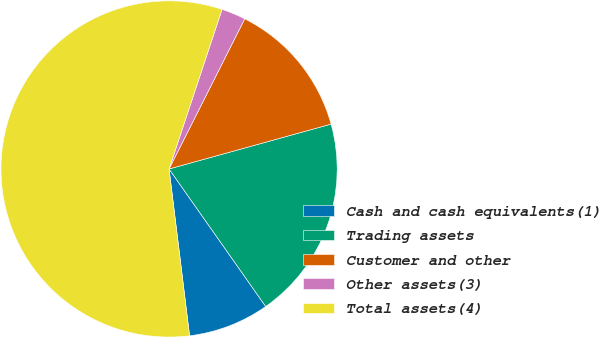<chart> <loc_0><loc_0><loc_500><loc_500><pie_chart><fcel>Cash and cash equivalents(1)<fcel>Trading assets<fcel>Customer and other<fcel>Other assets(3)<fcel>Total assets(4)<nl><fcel>7.8%<fcel>19.55%<fcel>13.27%<fcel>2.33%<fcel>57.05%<nl></chart> 